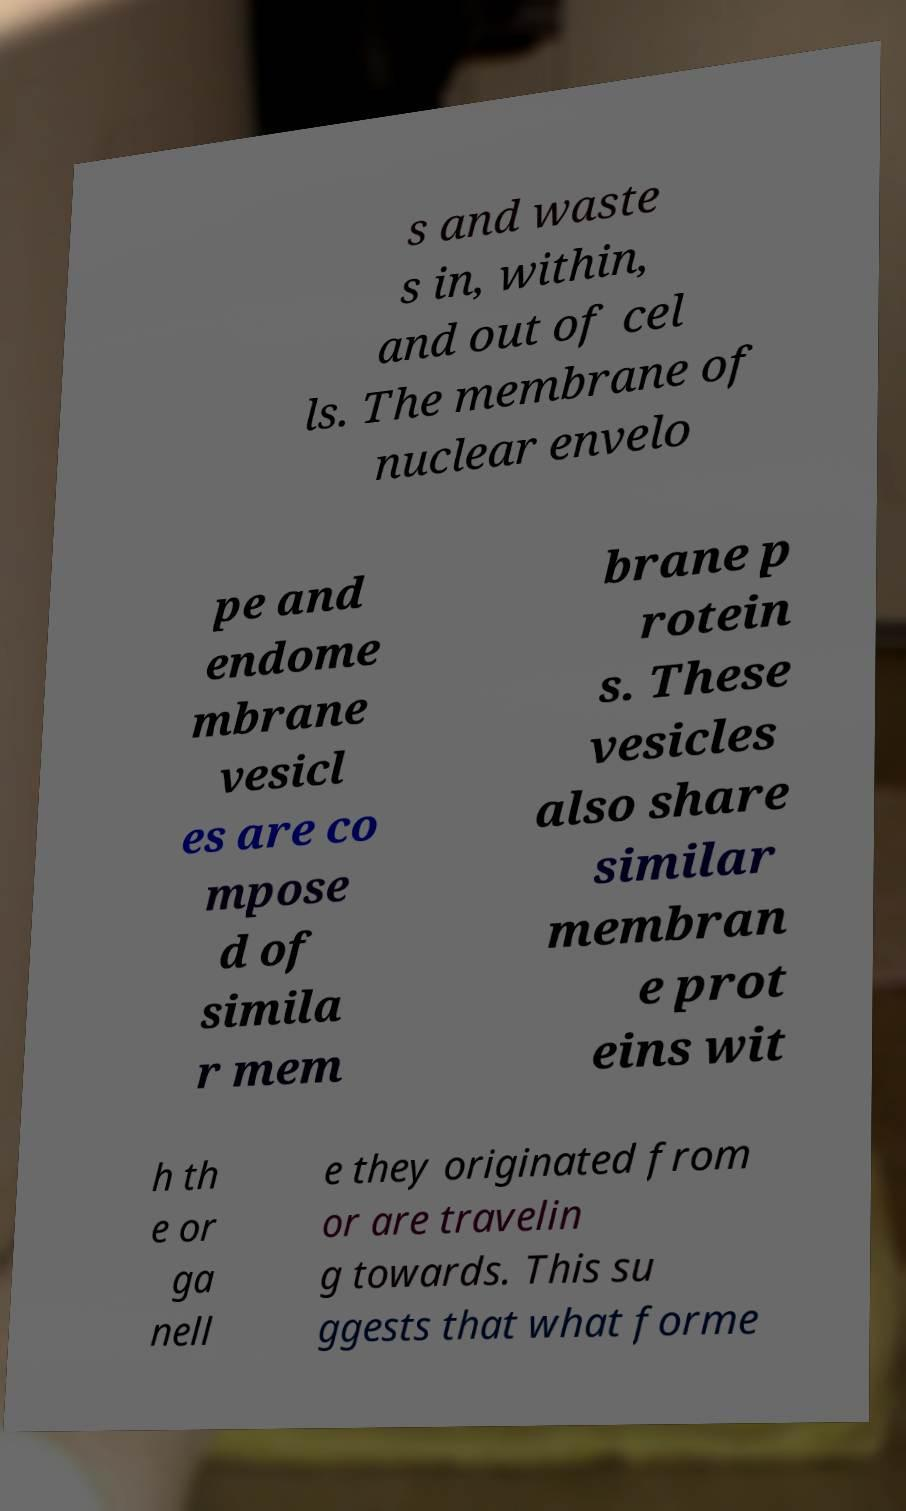What messages or text are displayed in this image? I need them in a readable, typed format. s and waste s in, within, and out of cel ls. The membrane of nuclear envelo pe and endome mbrane vesicl es are co mpose d of simila r mem brane p rotein s. These vesicles also share similar membran e prot eins wit h th e or ga nell e they originated from or are travelin g towards. This su ggests that what forme 